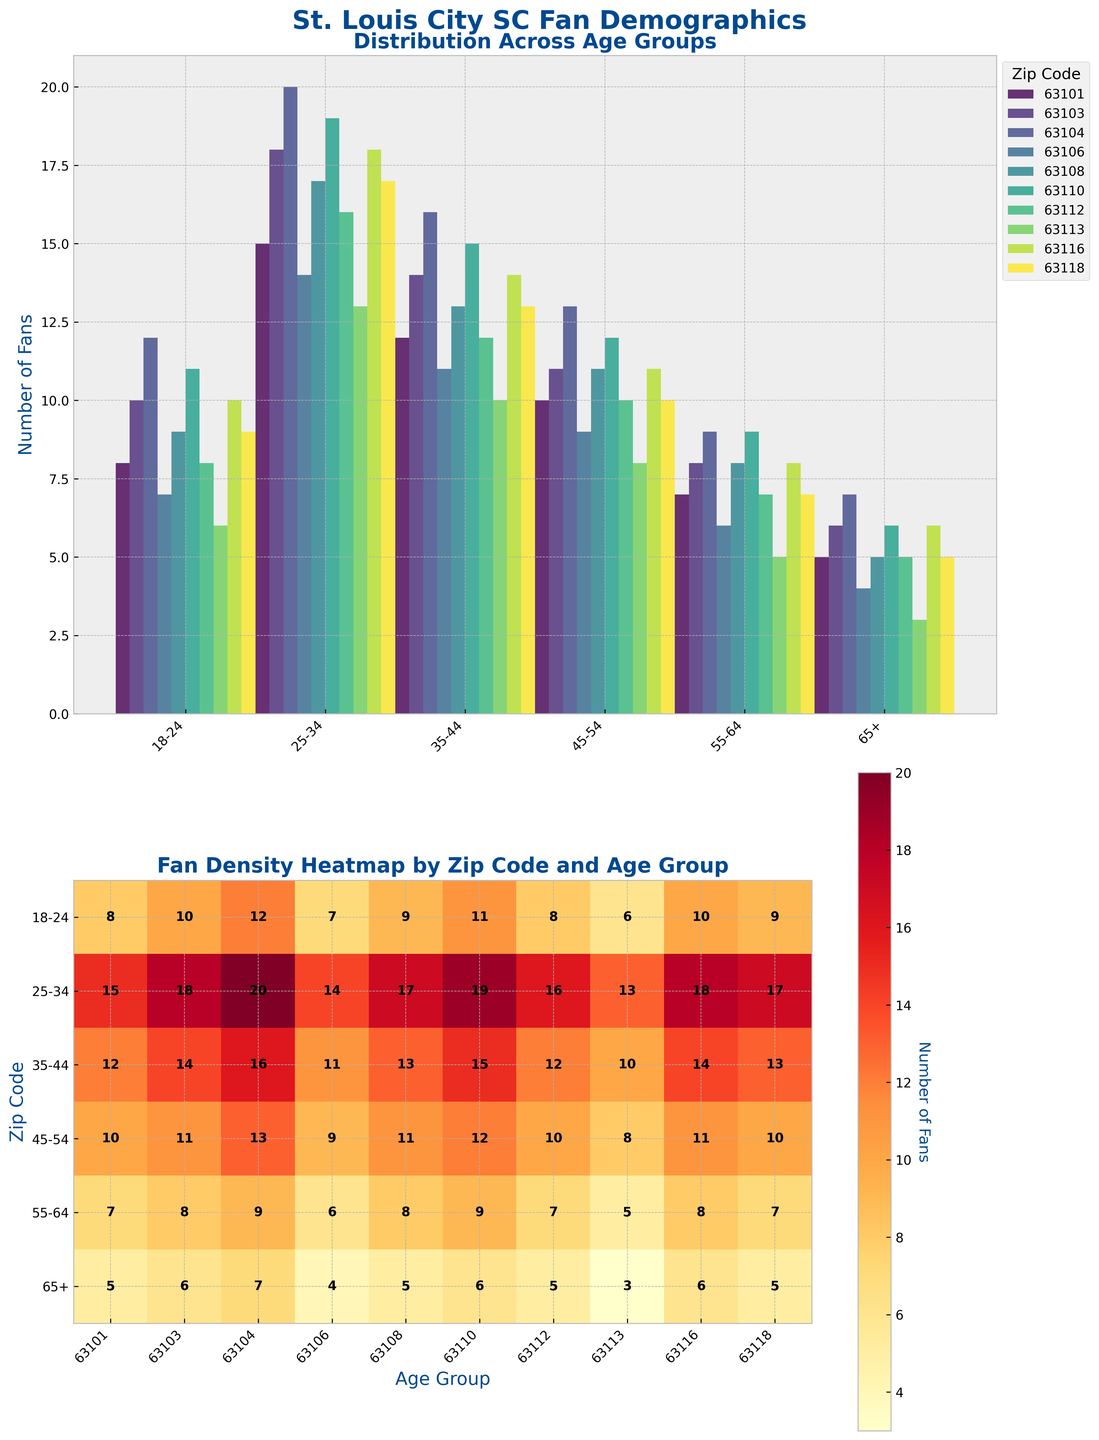What are the age groups listed on the x-axis of the upper plot? The x-axis of the upper plot represents the distribution of fans across various age groups. These age groups are labeled on the x-axis.
Answer: 18-24, 25-34, 35-44, 45-54, 55-64, 65+ What is the title of the heatmap in the lower subplot? The title of the heatmap provides information on what the heatmap represents, located at the top of the plot.
Answer: Fan Density Heatmap by Zip Code and Age Group Which zip code has the highest number of fans in the age group 25-34? To determine this, look at the second set of bars from the left in the upper plot and compare the heights. Zip code 63104 has the highest bar.
Answer: 63104 Between the age groups 35-44 and 55-64, which one has more fans across zip code 63101? Sum the number of fans in zip code 63101 for the age groups 35-44 (12) and 55-64 (7). Compare the sums to find which is greater.
Answer: 35-44 Which age group and zip code combination has the lowest number of fans in the heatmap? Look for the cell with the smallest value in the heatmap. The value "3" is the lowest, found at 65+ in zip code 63113.
Answer: 65+ in 63113 What is the total number of fans in zip code 63103 across all age groups? Sum the values for zip code 63103 across all age groups (10 + 18 + 14 + 11 + 8 + 6).
Answer: 67 How does the number of fans aged 18-24 in zip code 63108 compare to those in 63112? Compare the height of the bars corresponding to the age group 18-24 for zip codes 63108 (9) and 63112 (8).
Answer: 63108 has 1 more Is the age group 25-34 the most populous in all zip codes? Compare the height of all bars in the 25-34 age group across all zip codes to see if it is consistently the highest.
Answer: No Which age group shows the most uniform distribution across all zip codes? Check the bar heights for each age group to see which one has the most consistent (least variable) heights across all zip codes.
Answer: 35-44 What is the average number of fans in the age group 45-54 across all zip codes? Calculate the sum of fans in the age group 45-54 across all zip codes and divide by the number of zip codes (10). (10 + 11 + 13 + 9 + 11 + 12 + 10 + 8 + 11 + 10)/10
Answer: 10.5 